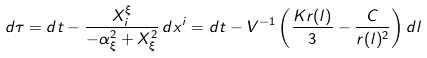Convert formula to latex. <formula><loc_0><loc_0><loc_500><loc_500>d \tau = d t - \frac { X ^ { \xi } _ { i } } { - \alpha _ { \xi } ^ { 2 } + X _ { \xi } ^ { 2 } } \, d x ^ { i } = d t - V ^ { - 1 } \left ( \frac { K r ( l ) } { 3 } - \frac { C } { r ( l ) ^ { 2 } } \right ) d l</formula> 